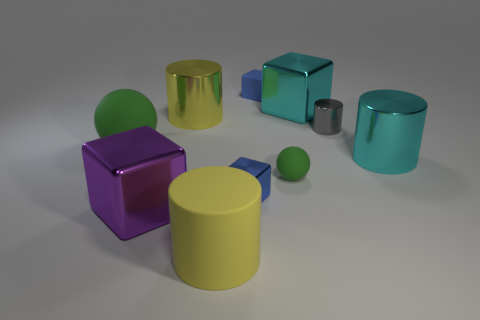What is the color of the large matte thing that is to the left of the cylinder that is in front of the purple shiny block? The large matte object to the left of the cylinder, which is in front of the purple shiny block, is a green sphere. To give you a little more context, this green sphere has a soft, diffused surface texture that distinguishes it from the shiny materials around it. 